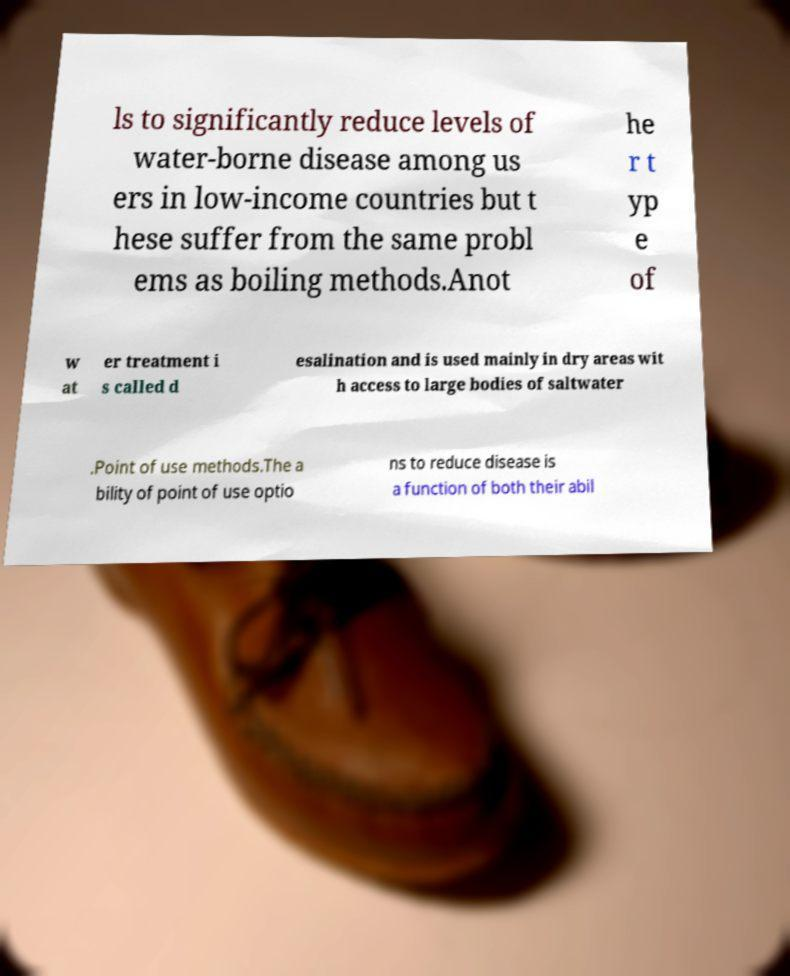I need the written content from this picture converted into text. Can you do that? ls to significantly reduce levels of water-borne disease among us ers in low-income countries but t hese suffer from the same probl ems as boiling methods.Anot he r t yp e of w at er treatment i s called d esalination and is used mainly in dry areas wit h access to large bodies of saltwater .Point of use methods.The a bility of point of use optio ns to reduce disease is a function of both their abil 